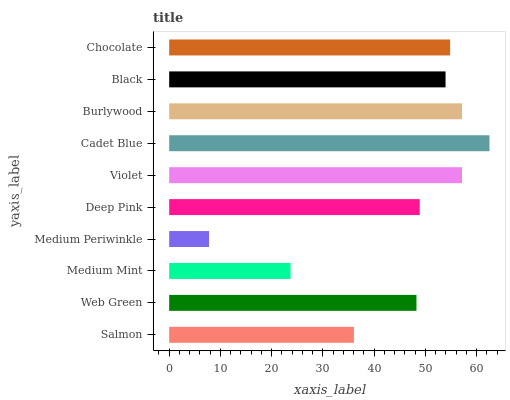Is Medium Periwinkle the minimum?
Answer yes or no. Yes. Is Cadet Blue the maximum?
Answer yes or no. Yes. Is Web Green the minimum?
Answer yes or no. No. Is Web Green the maximum?
Answer yes or no. No. Is Web Green greater than Salmon?
Answer yes or no. Yes. Is Salmon less than Web Green?
Answer yes or no. Yes. Is Salmon greater than Web Green?
Answer yes or no. No. Is Web Green less than Salmon?
Answer yes or no. No. Is Black the high median?
Answer yes or no. Yes. Is Deep Pink the low median?
Answer yes or no. Yes. Is Salmon the high median?
Answer yes or no. No. Is Burlywood the low median?
Answer yes or no. No. 